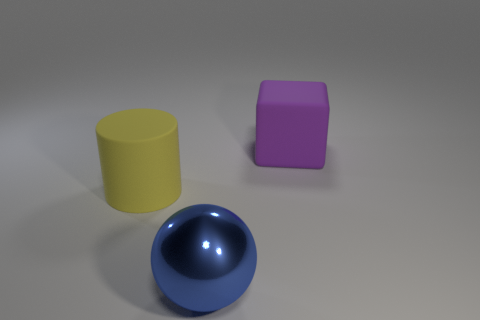Add 3 small cylinders. How many objects exist? 6 Subtract all cylinders. How many objects are left? 2 Subtract all big rubber blocks. Subtract all yellow rubber things. How many objects are left? 1 Add 2 large rubber things. How many large rubber things are left? 4 Add 1 large yellow objects. How many large yellow objects exist? 2 Subtract 0 purple cylinders. How many objects are left? 3 